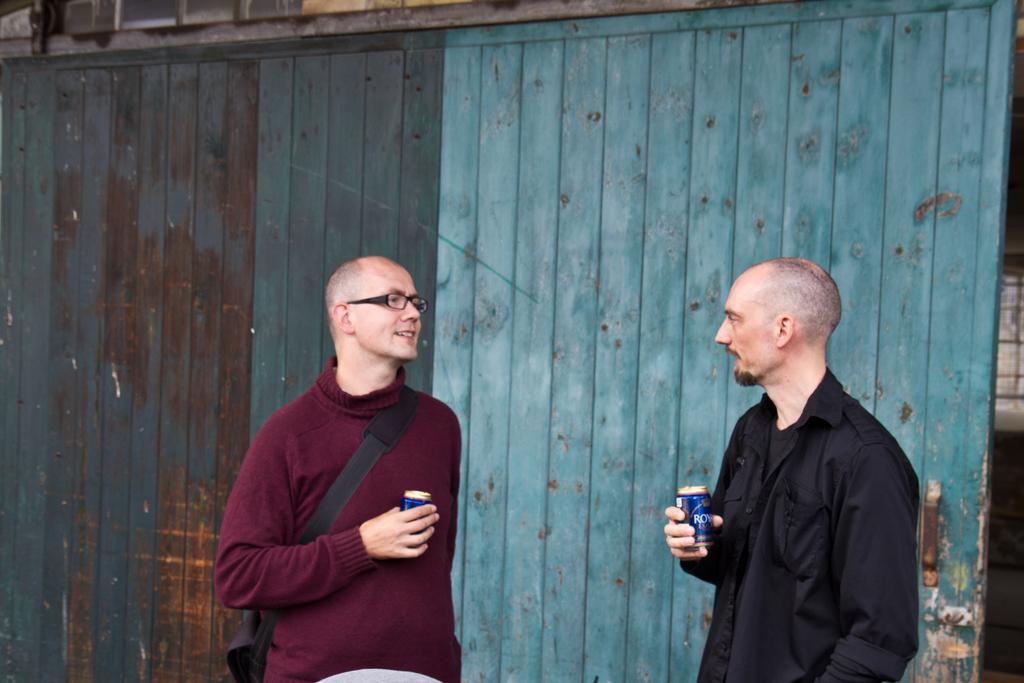In one or two sentences, can you explain what this image depicts? In this image I can see two men are standing, holding cock tins in their hands and it seems like both are speaking to each other. The man who is on the right side is wearing a black jacket. The man who is on the left side is wearing a t-shirt and a black color bag. In the background, I can see a wall made up of wood. 